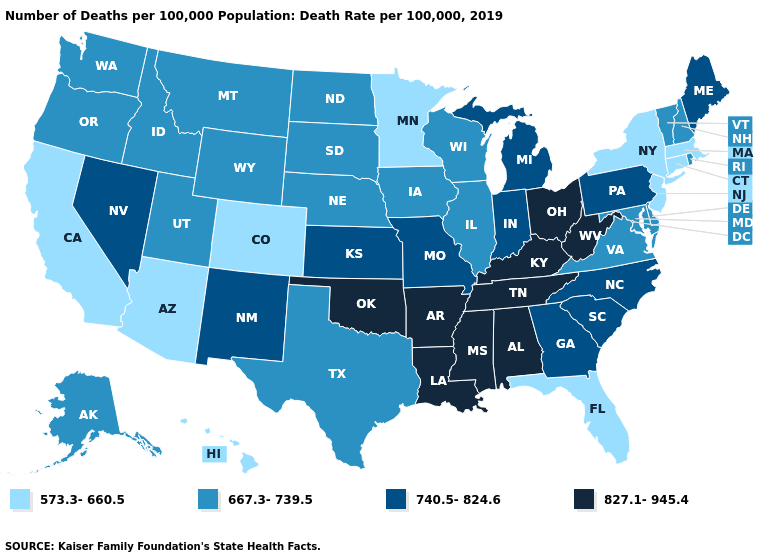Name the states that have a value in the range 573.3-660.5?
Concise answer only. Arizona, California, Colorado, Connecticut, Florida, Hawaii, Massachusetts, Minnesota, New Jersey, New York. Does Texas have the same value as New Mexico?
Quick response, please. No. Name the states that have a value in the range 667.3-739.5?
Concise answer only. Alaska, Delaware, Idaho, Illinois, Iowa, Maryland, Montana, Nebraska, New Hampshire, North Dakota, Oregon, Rhode Island, South Dakota, Texas, Utah, Vermont, Virginia, Washington, Wisconsin, Wyoming. Does Maine have the same value as Georgia?
Short answer required. Yes. Name the states that have a value in the range 827.1-945.4?
Short answer required. Alabama, Arkansas, Kentucky, Louisiana, Mississippi, Ohio, Oklahoma, Tennessee, West Virginia. What is the value of Nebraska?
Answer briefly. 667.3-739.5. What is the lowest value in the USA?
Short answer required. 573.3-660.5. Which states hav the highest value in the Northeast?
Give a very brief answer. Maine, Pennsylvania. Which states have the lowest value in the South?
Write a very short answer. Florida. What is the highest value in the West ?
Quick response, please. 740.5-824.6. What is the highest value in states that border North Dakota?
Answer briefly. 667.3-739.5. Does Massachusetts have the highest value in the USA?
Quick response, please. No. What is the highest value in the USA?
Concise answer only. 827.1-945.4. Name the states that have a value in the range 740.5-824.6?
Keep it brief. Georgia, Indiana, Kansas, Maine, Michigan, Missouri, Nevada, New Mexico, North Carolina, Pennsylvania, South Carolina. What is the highest value in states that border Virginia?
Be succinct. 827.1-945.4. 